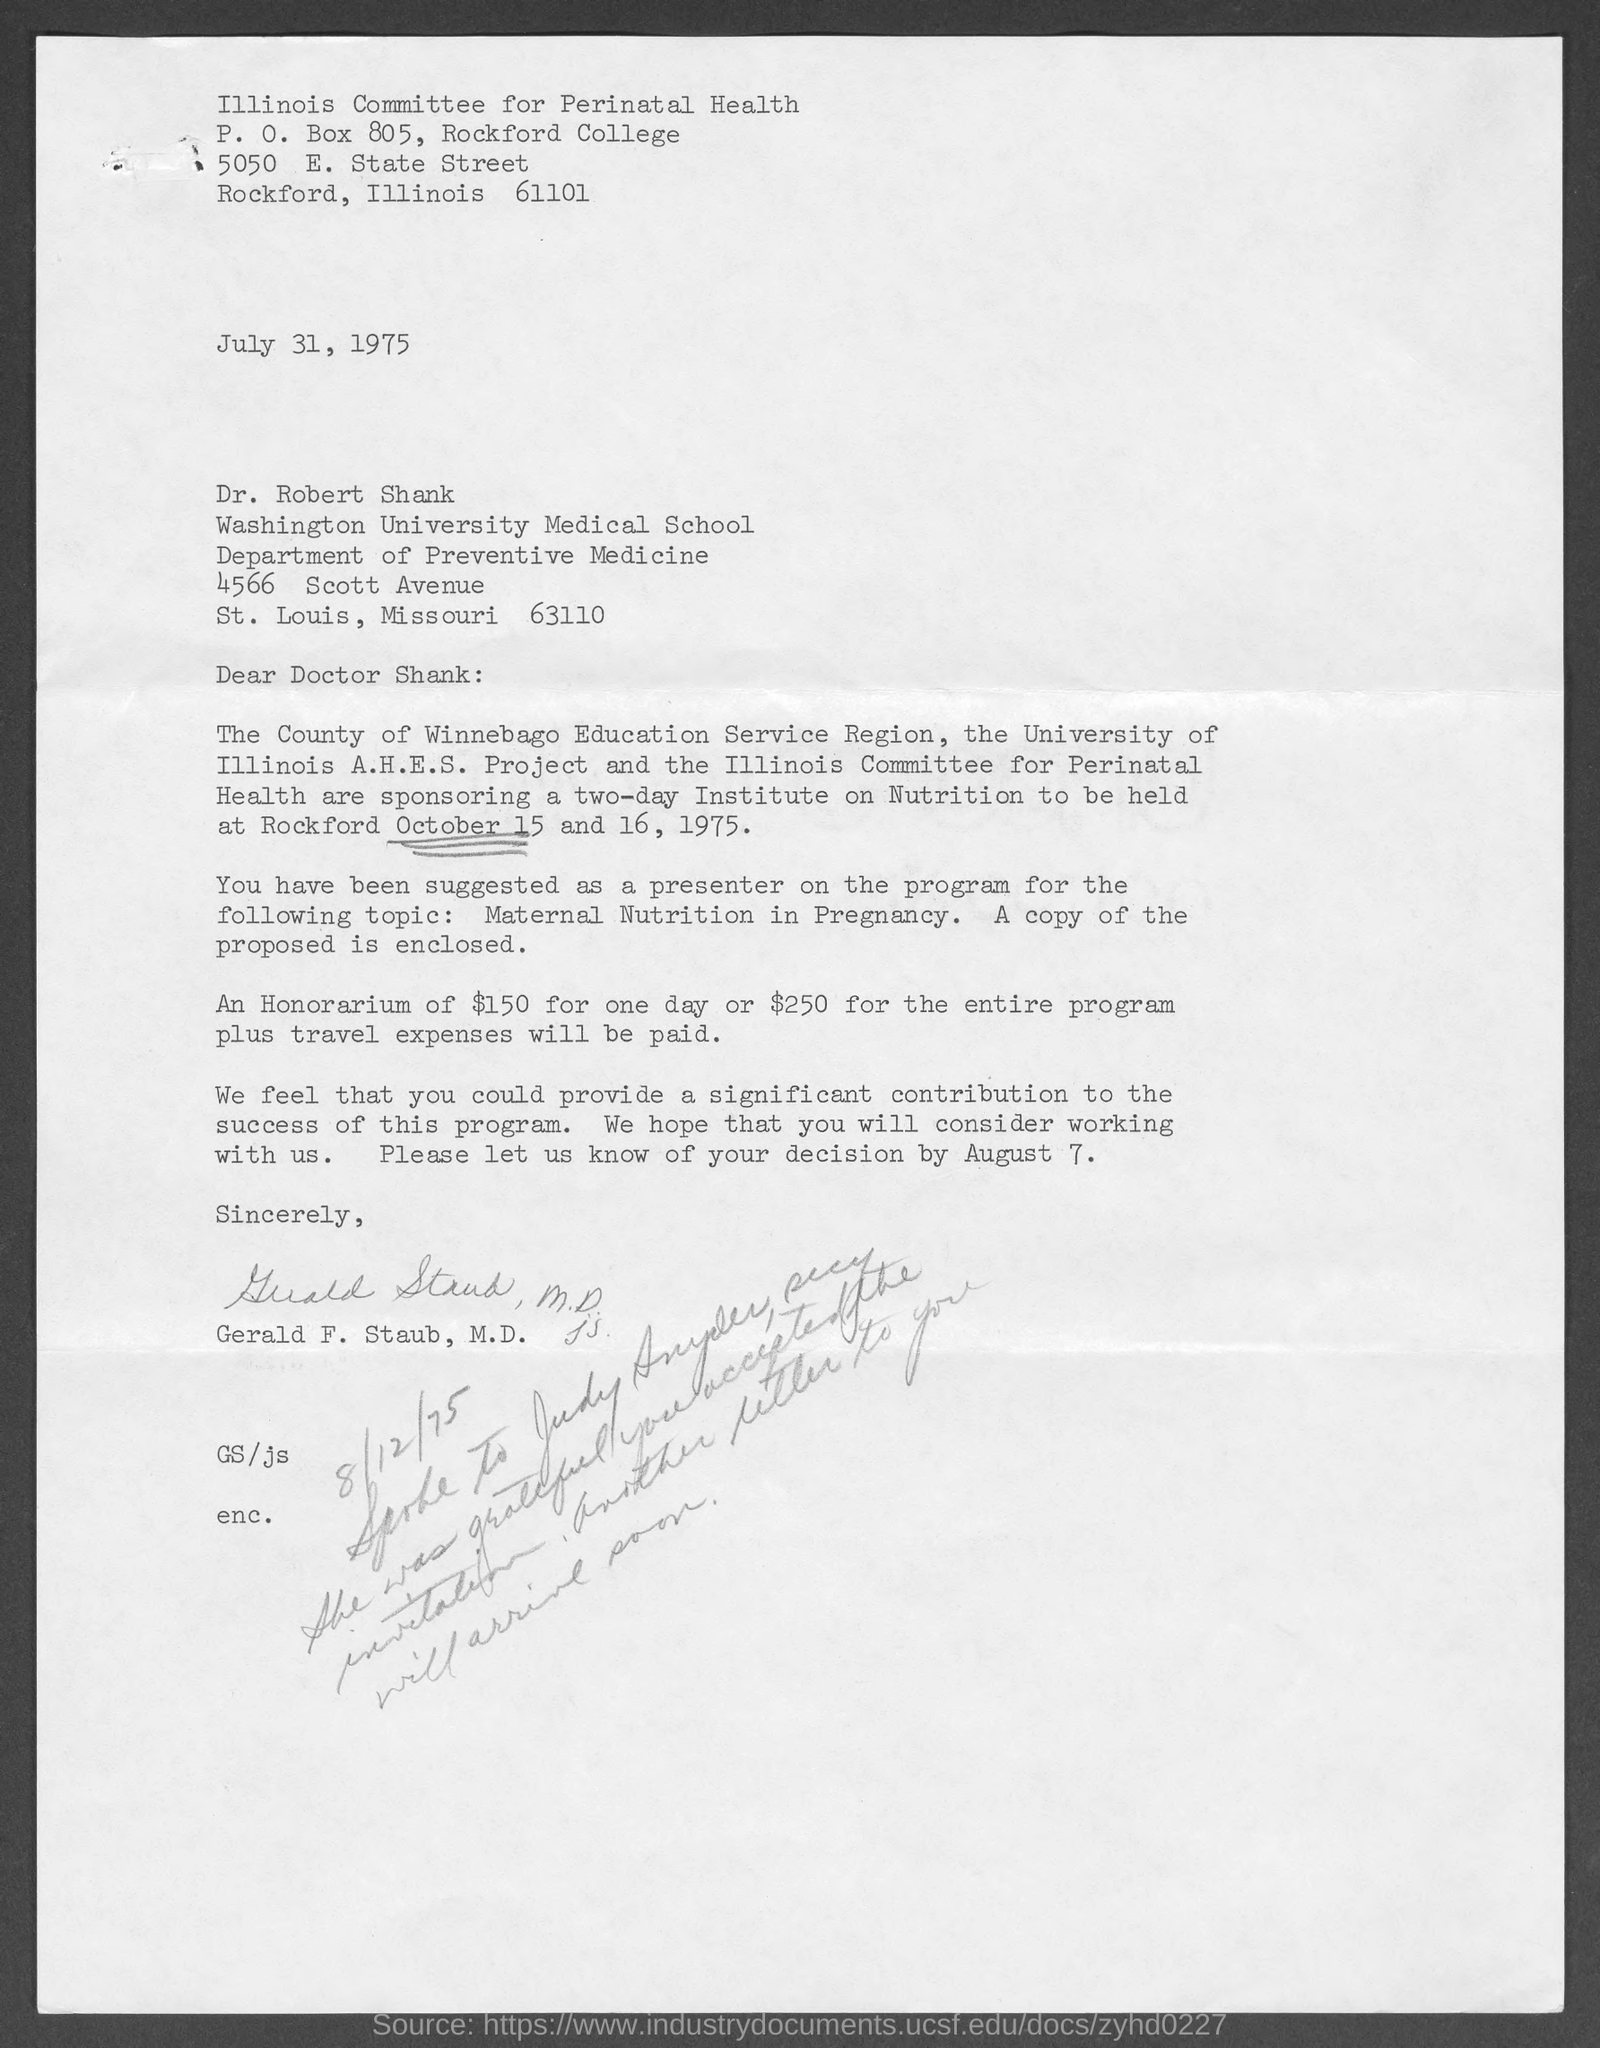Give some essential details in this illustration. The P.O. Box number mentioned in the letterhead is 805. The issued date of this letter is JULY 31, 1975. 